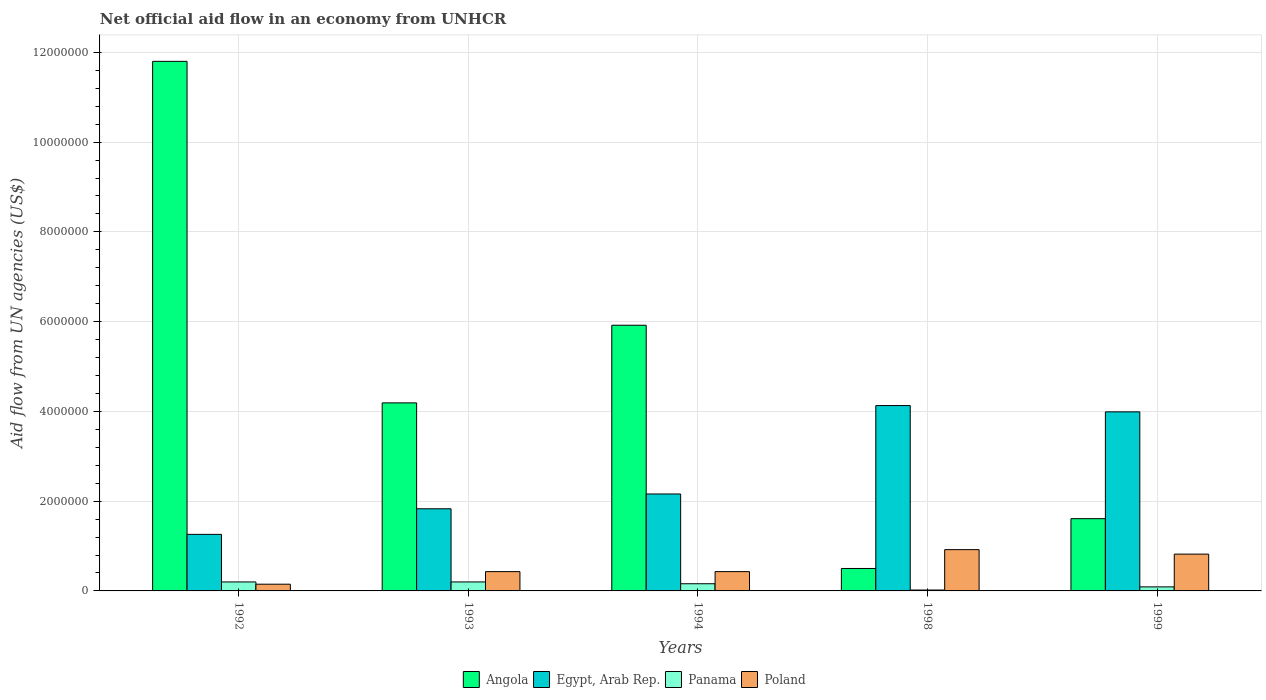How many different coloured bars are there?
Provide a short and direct response. 4. How many bars are there on the 1st tick from the left?
Your response must be concise. 4. How many bars are there on the 5th tick from the right?
Offer a terse response. 4. In how many cases, is the number of bars for a given year not equal to the number of legend labels?
Offer a very short reply. 0. What is the net official aid flow in Angola in 1994?
Your answer should be compact. 5.92e+06. Across all years, what is the maximum net official aid flow in Egypt, Arab Rep.?
Give a very brief answer. 4.13e+06. Across all years, what is the minimum net official aid flow in Egypt, Arab Rep.?
Ensure brevity in your answer.  1.26e+06. In which year was the net official aid flow in Poland maximum?
Keep it short and to the point. 1998. What is the total net official aid flow in Poland in the graph?
Offer a very short reply. 2.75e+06. What is the difference between the net official aid flow in Angola in 1992 and that in 1994?
Provide a succinct answer. 5.88e+06. What is the difference between the net official aid flow in Egypt, Arab Rep. in 1999 and the net official aid flow in Angola in 1994?
Ensure brevity in your answer.  -1.93e+06. In the year 1998, what is the difference between the net official aid flow in Poland and net official aid flow in Egypt, Arab Rep.?
Offer a very short reply. -3.21e+06. What is the ratio of the net official aid flow in Egypt, Arab Rep. in 1994 to that in 1999?
Ensure brevity in your answer.  0.54. In how many years, is the net official aid flow in Panama greater than the average net official aid flow in Panama taken over all years?
Give a very brief answer. 3. What does the 3rd bar from the left in 1999 represents?
Your response must be concise. Panama. What does the 4th bar from the right in 1994 represents?
Provide a short and direct response. Angola. Are all the bars in the graph horizontal?
Make the answer very short. No. What is the difference between two consecutive major ticks on the Y-axis?
Make the answer very short. 2.00e+06. Are the values on the major ticks of Y-axis written in scientific E-notation?
Provide a short and direct response. No. Does the graph contain grids?
Provide a short and direct response. Yes. Where does the legend appear in the graph?
Offer a terse response. Bottom center. How many legend labels are there?
Offer a terse response. 4. What is the title of the graph?
Ensure brevity in your answer.  Net official aid flow in an economy from UNHCR. Does "Vanuatu" appear as one of the legend labels in the graph?
Make the answer very short. No. What is the label or title of the X-axis?
Your response must be concise. Years. What is the label or title of the Y-axis?
Your response must be concise. Aid flow from UN agencies (US$). What is the Aid flow from UN agencies (US$) in Angola in 1992?
Make the answer very short. 1.18e+07. What is the Aid flow from UN agencies (US$) in Egypt, Arab Rep. in 1992?
Ensure brevity in your answer.  1.26e+06. What is the Aid flow from UN agencies (US$) in Poland in 1992?
Your answer should be very brief. 1.50e+05. What is the Aid flow from UN agencies (US$) of Angola in 1993?
Keep it short and to the point. 4.19e+06. What is the Aid flow from UN agencies (US$) in Egypt, Arab Rep. in 1993?
Your response must be concise. 1.83e+06. What is the Aid flow from UN agencies (US$) in Panama in 1993?
Your answer should be compact. 2.00e+05. What is the Aid flow from UN agencies (US$) in Angola in 1994?
Keep it short and to the point. 5.92e+06. What is the Aid flow from UN agencies (US$) of Egypt, Arab Rep. in 1994?
Your response must be concise. 2.16e+06. What is the Aid flow from UN agencies (US$) in Panama in 1994?
Give a very brief answer. 1.60e+05. What is the Aid flow from UN agencies (US$) of Egypt, Arab Rep. in 1998?
Offer a very short reply. 4.13e+06. What is the Aid flow from UN agencies (US$) in Panama in 1998?
Offer a very short reply. 2.00e+04. What is the Aid flow from UN agencies (US$) in Poland in 1998?
Provide a succinct answer. 9.20e+05. What is the Aid flow from UN agencies (US$) of Angola in 1999?
Offer a very short reply. 1.61e+06. What is the Aid flow from UN agencies (US$) of Egypt, Arab Rep. in 1999?
Give a very brief answer. 3.99e+06. What is the Aid flow from UN agencies (US$) of Panama in 1999?
Your answer should be compact. 9.00e+04. What is the Aid flow from UN agencies (US$) of Poland in 1999?
Give a very brief answer. 8.20e+05. Across all years, what is the maximum Aid flow from UN agencies (US$) of Angola?
Keep it short and to the point. 1.18e+07. Across all years, what is the maximum Aid flow from UN agencies (US$) in Egypt, Arab Rep.?
Make the answer very short. 4.13e+06. Across all years, what is the maximum Aid flow from UN agencies (US$) of Poland?
Give a very brief answer. 9.20e+05. Across all years, what is the minimum Aid flow from UN agencies (US$) of Angola?
Offer a terse response. 5.00e+05. Across all years, what is the minimum Aid flow from UN agencies (US$) of Egypt, Arab Rep.?
Your answer should be very brief. 1.26e+06. Across all years, what is the minimum Aid flow from UN agencies (US$) of Panama?
Your answer should be very brief. 2.00e+04. Across all years, what is the minimum Aid flow from UN agencies (US$) of Poland?
Make the answer very short. 1.50e+05. What is the total Aid flow from UN agencies (US$) of Angola in the graph?
Offer a terse response. 2.40e+07. What is the total Aid flow from UN agencies (US$) in Egypt, Arab Rep. in the graph?
Offer a very short reply. 1.34e+07. What is the total Aid flow from UN agencies (US$) of Panama in the graph?
Give a very brief answer. 6.70e+05. What is the total Aid flow from UN agencies (US$) in Poland in the graph?
Offer a very short reply. 2.75e+06. What is the difference between the Aid flow from UN agencies (US$) in Angola in 1992 and that in 1993?
Offer a very short reply. 7.61e+06. What is the difference between the Aid flow from UN agencies (US$) in Egypt, Arab Rep. in 1992 and that in 1993?
Your response must be concise. -5.70e+05. What is the difference between the Aid flow from UN agencies (US$) of Poland in 1992 and that in 1993?
Your response must be concise. -2.80e+05. What is the difference between the Aid flow from UN agencies (US$) in Angola in 1992 and that in 1994?
Offer a terse response. 5.88e+06. What is the difference between the Aid flow from UN agencies (US$) of Egypt, Arab Rep. in 1992 and that in 1994?
Offer a very short reply. -9.00e+05. What is the difference between the Aid flow from UN agencies (US$) of Panama in 1992 and that in 1994?
Give a very brief answer. 4.00e+04. What is the difference between the Aid flow from UN agencies (US$) of Poland in 1992 and that in 1994?
Your response must be concise. -2.80e+05. What is the difference between the Aid flow from UN agencies (US$) in Angola in 1992 and that in 1998?
Offer a terse response. 1.13e+07. What is the difference between the Aid flow from UN agencies (US$) of Egypt, Arab Rep. in 1992 and that in 1998?
Offer a very short reply. -2.87e+06. What is the difference between the Aid flow from UN agencies (US$) in Poland in 1992 and that in 1998?
Give a very brief answer. -7.70e+05. What is the difference between the Aid flow from UN agencies (US$) in Angola in 1992 and that in 1999?
Offer a very short reply. 1.02e+07. What is the difference between the Aid flow from UN agencies (US$) in Egypt, Arab Rep. in 1992 and that in 1999?
Provide a short and direct response. -2.73e+06. What is the difference between the Aid flow from UN agencies (US$) in Poland in 1992 and that in 1999?
Keep it short and to the point. -6.70e+05. What is the difference between the Aid flow from UN agencies (US$) of Angola in 1993 and that in 1994?
Provide a short and direct response. -1.73e+06. What is the difference between the Aid flow from UN agencies (US$) in Egypt, Arab Rep. in 1993 and that in 1994?
Your answer should be very brief. -3.30e+05. What is the difference between the Aid flow from UN agencies (US$) of Poland in 1993 and that in 1994?
Your answer should be compact. 0. What is the difference between the Aid flow from UN agencies (US$) of Angola in 1993 and that in 1998?
Your response must be concise. 3.69e+06. What is the difference between the Aid flow from UN agencies (US$) of Egypt, Arab Rep. in 1993 and that in 1998?
Your answer should be very brief. -2.30e+06. What is the difference between the Aid flow from UN agencies (US$) in Panama in 1993 and that in 1998?
Provide a succinct answer. 1.80e+05. What is the difference between the Aid flow from UN agencies (US$) in Poland in 1993 and that in 1998?
Your answer should be compact. -4.90e+05. What is the difference between the Aid flow from UN agencies (US$) of Angola in 1993 and that in 1999?
Provide a short and direct response. 2.58e+06. What is the difference between the Aid flow from UN agencies (US$) in Egypt, Arab Rep. in 1993 and that in 1999?
Your answer should be compact. -2.16e+06. What is the difference between the Aid flow from UN agencies (US$) in Poland in 1993 and that in 1999?
Make the answer very short. -3.90e+05. What is the difference between the Aid flow from UN agencies (US$) in Angola in 1994 and that in 1998?
Offer a terse response. 5.42e+06. What is the difference between the Aid flow from UN agencies (US$) in Egypt, Arab Rep. in 1994 and that in 1998?
Your answer should be compact. -1.97e+06. What is the difference between the Aid flow from UN agencies (US$) of Poland in 1994 and that in 1998?
Keep it short and to the point. -4.90e+05. What is the difference between the Aid flow from UN agencies (US$) in Angola in 1994 and that in 1999?
Keep it short and to the point. 4.31e+06. What is the difference between the Aid flow from UN agencies (US$) in Egypt, Arab Rep. in 1994 and that in 1999?
Ensure brevity in your answer.  -1.83e+06. What is the difference between the Aid flow from UN agencies (US$) of Panama in 1994 and that in 1999?
Offer a very short reply. 7.00e+04. What is the difference between the Aid flow from UN agencies (US$) in Poland in 1994 and that in 1999?
Offer a very short reply. -3.90e+05. What is the difference between the Aid flow from UN agencies (US$) in Angola in 1998 and that in 1999?
Provide a succinct answer. -1.11e+06. What is the difference between the Aid flow from UN agencies (US$) in Panama in 1998 and that in 1999?
Give a very brief answer. -7.00e+04. What is the difference between the Aid flow from UN agencies (US$) in Poland in 1998 and that in 1999?
Give a very brief answer. 1.00e+05. What is the difference between the Aid flow from UN agencies (US$) in Angola in 1992 and the Aid flow from UN agencies (US$) in Egypt, Arab Rep. in 1993?
Your answer should be very brief. 9.97e+06. What is the difference between the Aid flow from UN agencies (US$) of Angola in 1992 and the Aid flow from UN agencies (US$) of Panama in 1993?
Your answer should be very brief. 1.16e+07. What is the difference between the Aid flow from UN agencies (US$) in Angola in 1992 and the Aid flow from UN agencies (US$) in Poland in 1993?
Your answer should be very brief. 1.14e+07. What is the difference between the Aid flow from UN agencies (US$) of Egypt, Arab Rep. in 1992 and the Aid flow from UN agencies (US$) of Panama in 1993?
Keep it short and to the point. 1.06e+06. What is the difference between the Aid flow from UN agencies (US$) in Egypt, Arab Rep. in 1992 and the Aid flow from UN agencies (US$) in Poland in 1993?
Give a very brief answer. 8.30e+05. What is the difference between the Aid flow from UN agencies (US$) of Panama in 1992 and the Aid flow from UN agencies (US$) of Poland in 1993?
Keep it short and to the point. -2.30e+05. What is the difference between the Aid flow from UN agencies (US$) in Angola in 1992 and the Aid flow from UN agencies (US$) in Egypt, Arab Rep. in 1994?
Your answer should be compact. 9.64e+06. What is the difference between the Aid flow from UN agencies (US$) of Angola in 1992 and the Aid flow from UN agencies (US$) of Panama in 1994?
Keep it short and to the point. 1.16e+07. What is the difference between the Aid flow from UN agencies (US$) of Angola in 1992 and the Aid flow from UN agencies (US$) of Poland in 1994?
Offer a very short reply. 1.14e+07. What is the difference between the Aid flow from UN agencies (US$) of Egypt, Arab Rep. in 1992 and the Aid flow from UN agencies (US$) of Panama in 1994?
Provide a short and direct response. 1.10e+06. What is the difference between the Aid flow from UN agencies (US$) in Egypt, Arab Rep. in 1992 and the Aid flow from UN agencies (US$) in Poland in 1994?
Offer a very short reply. 8.30e+05. What is the difference between the Aid flow from UN agencies (US$) of Panama in 1992 and the Aid flow from UN agencies (US$) of Poland in 1994?
Provide a succinct answer. -2.30e+05. What is the difference between the Aid flow from UN agencies (US$) in Angola in 1992 and the Aid flow from UN agencies (US$) in Egypt, Arab Rep. in 1998?
Provide a short and direct response. 7.67e+06. What is the difference between the Aid flow from UN agencies (US$) of Angola in 1992 and the Aid flow from UN agencies (US$) of Panama in 1998?
Your response must be concise. 1.18e+07. What is the difference between the Aid flow from UN agencies (US$) in Angola in 1992 and the Aid flow from UN agencies (US$) in Poland in 1998?
Provide a succinct answer. 1.09e+07. What is the difference between the Aid flow from UN agencies (US$) in Egypt, Arab Rep. in 1992 and the Aid flow from UN agencies (US$) in Panama in 1998?
Make the answer very short. 1.24e+06. What is the difference between the Aid flow from UN agencies (US$) of Egypt, Arab Rep. in 1992 and the Aid flow from UN agencies (US$) of Poland in 1998?
Provide a short and direct response. 3.40e+05. What is the difference between the Aid flow from UN agencies (US$) in Panama in 1992 and the Aid flow from UN agencies (US$) in Poland in 1998?
Provide a succinct answer. -7.20e+05. What is the difference between the Aid flow from UN agencies (US$) of Angola in 1992 and the Aid flow from UN agencies (US$) of Egypt, Arab Rep. in 1999?
Provide a succinct answer. 7.81e+06. What is the difference between the Aid flow from UN agencies (US$) in Angola in 1992 and the Aid flow from UN agencies (US$) in Panama in 1999?
Offer a terse response. 1.17e+07. What is the difference between the Aid flow from UN agencies (US$) of Angola in 1992 and the Aid flow from UN agencies (US$) of Poland in 1999?
Keep it short and to the point. 1.10e+07. What is the difference between the Aid flow from UN agencies (US$) in Egypt, Arab Rep. in 1992 and the Aid flow from UN agencies (US$) in Panama in 1999?
Make the answer very short. 1.17e+06. What is the difference between the Aid flow from UN agencies (US$) of Panama in 1992 and the Aid flow from UN agencies (US$) of Poland in 1999?
Offer a terse response. -6.20e+05. What is the difference between the Aid flow from UN agencies (US$) in Angola in 1993 and the Aid flow from UN agencies (US$) in Egypt, Arab Rep. in 1994?
Your response must be concise. 2.03e+06. What is the difference between the Aid flow from UN agencies (US$) of Angola in 1993 and the Aid flow from UN agencies (US$) of Panama in 1994?
Keep it short and to the point. 4.03e+06. What is the difference between the Aid flow from UN agencies (US$) in Angola in 1993 and the Aid flow from UN agencies (US$) in Poland in 1994?
Your answer should be very brief. 3.76e+06. What is the difference between the Aid flow from UN agencies (US$) in Egypt, Arab Rep. in 1993 and the Aid flow from UN agencies (US$) in Panama in 1994?
Offer a very short reply. 1.67e+06. What is the difference between the Aid flow from UN agencies (US$) in Egypt, Arab Rep. in 1993 and the Aid flow from UN agencies (US$) in Poland in 1994?
Provide a short and direct response. 1.40e+06. What is the difference between the Aid flow from UN agencies (US$) in Panama in 1993 and the Aid flow from UN agencies (US$) in Poland in 1994?
Your response must be concise. -2.30e+05. What is the difference between the Aid flow from UN agencies (US$) in Angola in 1993 and the Aid flow from UN agencies (US$) in Egypt, Arab Rep. in 1998?
Keep it short and to the point. 6.00e+04. What is the difference between the Aid flow from UN agencies (US$) in Angola in 1993 and the Aid flow from UN agencies (US$) in Panama in 1998?
Your response must be concise. 4.17e+06. What is the difference between the Aid flow from UN agencies (US$) of Angola in 1993 and the Aid flow from UN agencies (US$) of Poland in 1998?
Provide a succinct answer. 3.27e+06. What is the difference between the Aid flow from UN agencies (US$) in Egypt, Arab Rep. in 1993 and the Aid flow from UN agencies (US$) in Panama in 1998?
Give a very brief answer. 1.81e+06. What is the difference between the Aid flow from UN agencies (US$) in Egypt, Arab Rep. in 1993 and the Aid flow from UN agencies (US$) in Poland in 1998?
Provide a short and direct response. 9.10e+05. What is the difference between the Aid flow from UN agencies (US$) in Panama in 1993 and the Aid flow from UN agencies (US$) in Poland in 1998?
Give a very brief answer. -7.20e+05. What is the difference between the Aid flow from UN agencies (US$) in Angola in 1993 and the Aid flow from UN agencies (US$) in Panama in 1999?
Offer a terse response. 4.10e+06. What is the difference between the Aid flow from UN agencies (US$) of Angola in 1993 and the Aid flow from UN agencies (US$) of Poland in 1999?
Offer a very short reply. 3.37e+06. What is the difference between the Aid flow from UN agencies (US$) of Egypt, Arab Rep. in 1993 and the Aid flow from UN agencies (US$) of Panama in 1999?
Your response must be concise. 1.74e+06. What is the difference between the Aid flow from UN agencies (US$) in Egypt, Arab Rep. in 1993 and the Aid flow from UN agencies (US$) in Poland in 1999?
Your answer should be very brief. 1.01e+06. What is the difference between the Aid flow from UN agencies (US$) in Panama in 1993 and the Aid flow from UN agencies (US$) in Poland in 1999?
Your response must be concise. -6.20e+05. What is the difference between the Aid flow from UN agencies (US$) in Angola in 1994 and the Aid flow from UN agencies (US$) in Egypt, Arab Rep. in 1998?
Give a very brief answer. 1.79e+06. What is the difference between the Aid flow from UN agencies (US$) in Angola in 1994 and the Aid flow from UN agencies (US$) in Panama in 1998?
Provide a succinct answer. 5.90e+06. What is the difference between the Aid flow from UN agencies (US$) of Angola in 1994 and the Aid flow from UN agencies (US$) of Poland in 1998?
Provide a short and direct response. 5.00e+06. What is the difference between the Aid flow from UN agencies (US$) in Egypt, Arab Rep. in 1994 and the Aid flow from UN agencies (US$) in Panama in 1998?
Offer a very short reply. 2.14e+06. What is the difference between the Aid flow from UN agencies (US$) in Egypt, Arab Rep. in 1994 and the Aid flow from UN agencies (US$) in Poland in 1998?
Offer a terse response. 1.24e+06. What is the difference between the Aid flow from UN agencies (US$) in Panama in 1994 and the Aid flow from UN agencies (US$) in Poland in 1998?
Give a very brief answer. -7.60e+05. What is the difference between the Aid flow from UN agencies (US$) in Angola in 1994 and the Aid flow from UN agencies (US$) in Egypt, Arab Rep. in 1999?
Ensure brevity in your answer.  1.93e+06. What is the difference between the Aid flow from UN agencies (US$) in Angola in 1994 and the Aid flow from UN agencies (US$) in Panama in 1999?
Your response must be concise. 5.83e+06. What is the difference between the Aid flow from UN agencies (US$) of Angola in 1994 and the Aid flow from UN agencies (US$) of Poland in 1999?
Offer a very short reply. 5.10e+06. What is the difference between the Aid flow from UN agencies (US$) in Egypt, Arab Rep. in 1994 and the Aid flow from UN agencies (US$) in Panama in 1999?
Give a very brief answer. 2.07e+06. What is the difference between the Aid flow from UN agencies (US$) in Egypt, Arab Rep. in 1994 and the Aid flow from UN agencies (US$) in Poland in 1999?
Keep it short and to the point. 1.34e+06. What is the difference between the Aid flow from UN agencies (US$) in Panama in 1994 and the Aid flow from UN agencies (US$) in Poland in 1999?
Give a very brief answer. -6.60e+05. What is the difference between the Aid flow from UN agencies (US$) in Angola in 1998 and the Aid flow from UN agencies (US$) in Egypt, Arab Rep. in 1999?
Your answer should be very brief. -3.49e+06. What is the difference between the Aid flow from UN agencies (US$) of Angola in 1998 and the Aid flow from UN agencies (US$) of Panama in 1999?
Offer a very short reply. 4.10e+05. What is the difference between the Aid flow from UN agencies (US$) in Angola in 1998 and the Aid flow from UN agencies (US$) in Poland in 1999?
Make the answer very short. -3.20e+05. What is the difference between the Aid flow from UN agencies (US$) of Egypt, Arab Rep. in 1998 and the Aid flow from UN agencies (US$) of Panama in 1999?
Your answer should be compact. 4.04e+06. What is the difference between the Aid flow from UN agencies (US$) of Egypt, Arab Rep. in 1998 and the Aid flow from UN agencies (US$) of Poland in 1999?
Give a very brief answer. 3.31e+06. What is the difference between the Aid flow from UN agencies (US$) of Panama in 1998 and the Aid flow from UN agencies (US$) of Poland in 1999?
Provide a succinct answer. -8.00e+05. What is the average Aid flow from UN agencies (US$) in Angola per year?
Offer a very short reply. 4.80e+06. What is the average Aid flow from UN agencies (US$) in Egypt, Arab Rep. per year?
Offer a terse response. 2.67e+06. What is the average Aid flow from UN agencies (US$) in Panama per year?
Keep it short and to the point. 1.34e+05. What is the average Aid flow from UN agencies (US$) in Poland per year?
Your response must be concise. 5.50e+05. In the year 1992, what is the difference between the Aid flow from UN agencies (US$) in Angola and Aid flow from UN agencies (US$) in Egypt, Arab Rep.?
Provide a short and direct response. 1.05e+07. In the year 1992, what is the difference between the Aid flow from UN agencies (US$) of Angola and Aid flow from UN agencies (US$) of Panama?
Give a very brief answer. 1.16e+07. In the year 1992, what is the difference between the Aid flow from UN agencies (US$) in Angola and Aid flow from UN agencies (US$) in Poland?
Provide a succinct answer. 1.16e+07. In the year 1992, what is the difference between the Aid flow from UN agencies (US$) in Egypt, Arab Rep. and Aid flow from UN agencies (US$) in Panama?
Keep it short and to the point. 1.06e+06. In the year 1992, what is the difference between the Aid flow from UN agencies (US$) in Egypt, Arab Rep. and Aid flow from UN agencies (US$) in Poland?
Give a very brief answer. 1.11e+06. In the year 1992, what is the difference between the Aid flow from UN agencies (US$) in Panama and Aid flow from UN agencies (US$) in Poland?
Keep it short and to the point. 5.00e+04. In the year 1993, what is the difference between the Aid flow from UN agencies (US$) in Angola and Aid flow from UN agencies (US$) in Egypt, Arab Rep.?
Ensure brevity in your answer.  2.36e+06. In the year 1993, what is the difference between the Aid flow from UN agencies (US$) in Angola and Aid flow from UN agencies (US$) in Panama?
Provide a short and direct response. 3.99e+06. In the year 1993, what is the difference between the Aid flow from UN agencies (US$) of Angola and Aid flow from UN agencies (US$) of Poland?
Offer a terse response. 3.76e+06. In the year 1993, what is the difference between the Aid flow from UN agencies (US$) in Egypt, Arab Rep. and Aid flow from UN agencies (US$) in Panama?
Your answer should be compact. 1.63e+06. In the year 1993, what is the difference between the Aid flow from UN agencies (US$) of Egypt, Arab Rep. and Aid flow from UN agencies (US$) of Poland?
Your answer should be compact. 1.40e+06. In the year 1993, what is the difference between the Aid flow from UN agencies (US$) in Panama and Aid flow from UN agencies (US$) in Poland?
Provide a succinct answer. -2.30e+05. In the year 1994, what is the difference between the Aid flow from UN agencies (US$) of Angola and Aid flow from UN agencies (US$) of Egypt, Arab Rep.?
Your answer should be very brief. 3.76e+06. In the year 1994, what is the difference between the Aid flow from UN agencies (US$) of Angola and Aid flow from UN agencies (US$) of Panama?
Keep it short and to the point. 5.76e+06. In the year 1994, what is the difference between the Aid flow from UN agencies (US$) in Angola and Aid flow from UN agencies (US$) in Poland?
Keep it short and to the point. 5.49e+06. In the year 1994, what is the difference between the Aid flow from UN agencies (US$) of Egypt, Arab Rep. and Aid flow from UN agencies (US$) of Poland?
Your answer should be compact. 1.73e+06. In the year 1998, what is the difference between the Aid flow from UN agencies (US$) in Angola and Aid flow from UN agencies (US$) in Egypt, Arab Rep.?
Make the answer very short. -3.63e+06. In the year 1998, what is the difference between the Aid flow from UN agencies (US$) in Angola and Aid flow from UN agencies (US$) in Poland?
Offer a terse response. -4.20e+05. In the year 1998, what is the difference between the Aid flow from UN agencies (US$) in Egypt, Arab Rep. and Aid flow from UN agencies (US$) in Panama?
Ensure brevity in your answer.  4.11e+06. In the year 1998, what is the difference between the Aid flow from UN agencies (US$) of Egypt, Arab Rep. and Aid flow from UN agencies (US$) of Poland?
Provide a succinct answer. 3.21e+06. In the year 1998, what is the difference between the Aid flow from UN agencies (US$) in Panama and Aid flow from UN agencies (US$) in Poland?
Ensure brevity in your answer.  -9.00e+05. In the year 1999, what is the difference between the Aid flow from UN agencies (US$) of Angola and Aid flow from UN agencies (US$) of Egypt, Arab Rep.?
Your answer should be compact. -2.38e+06. In the year 1999, what is the difference between the Aid flow from UN agencies (US$) of Angola and Aid flow from UN agencies (US$) of Panama?
Offer a very short reply. 1.52e+06. In the year 1999, what is the difference between the Aid flow from UN agencies (US$) in Angola and Aid flow from UN agencies (US$) in Poland?
Give a very brief answer. 7.90e+05. In the year 1999, what is the difference between the Aid flow from UN agencies (US$) of Egypt, Arab Rep. and Aid flow from UN agencies (US$) of Panama?
Offer a very short reply. 3.90e+06. In the year 1999, what is the difference between the Aid flow from UN agencies (US$) of Egypt, Arab Rep. and Aid flow from UN agencies (US$) of Poland?
Your answer should be very brief. 3.17e+06. In the year 1999, what is the difference between the Aid flow from UN agencies (US$) in Panama and Aid flow from UN agencies (US$) in Poland?
Provide a succinct answer. -7.30e+05. What is the ratio of the Aid flow from UN agencies (US$) of Angola in 1992 to that in 1993?
Your answer should be compact. 2.82. What is the ratio of the Aid flow from UN agencies (US$) of Egypt, Arab Rep. in 1992 to that in 1993?
Make the answer very short. 0.69. What is the ratio of the Aid flow from UN agencies (US$) in Panama in 1992 to that in 1993?
Offer a terse response. 1. What is the ratio of the Aid flow from UN agencies (US$) of Poland in 1992 to that in 1993?
Provide a succinct answer. 0.35. What is the ratio of the Aid flow from UN agencies (US$) in Angola in 1992 to that in 1994?
Your answer should be very brief. 1.99. What is the ratio of the Aid flow from UN agencies (US$) in Egypt, Arab Rep. in 1992 to that in 1994?
Keep it short and to the point. 0.58. What is the ratio of the Aid flow from UN agencies (US$) of Panama in 1992 to that in 1994?
Offer a very short reply. 1.25. What is the ratio of the Aid flow from UN agencies (US$) in Poland in 1992 to that in 1994?
Provide a succinct answer. 0.35. What is the ratio of the Aid flow from UN agencies (US$) in Angola in 1992 to that in 1998?
Provide a succinct answer. 23.6. What is the ratio of the Aid flow from UN agencies (US$) of Egypt, Arab Rep. in 1992 to that in 1998?
Your answer should be very brief. 0.31. What is the ratio of the Aid flow from UN agencies (US$) of Poland in 1992 to that in 1998?
Your response must be concise. 0.16. What is the ratio of the Aid flow from UN agencies (US$) of Angola in 1992 to that in 1999?
Ensure brevity in your answer.  7.33. What is the ratio of the Aid flow from UN agencies (US$) in Egypt, Arab Rep. in 1992 to that in 1999?
Ensure brevity in your answer.  0.32. What is the ratio of the Aid flow from UN agencies (US$) in Panama in 1992 to that in 1999?
Give a very brief answer. 2.22. What is the ratio of the Aid flow from UN agencies (US$) of Poland in 1992 to that in 1999?
Provide a short and direct response. 0.18. What is the ratio of the Aid flow from UN agencies (US$) in Angola in 1993 to that in 1994?
Your answer should be compact. 0.71. What is the ratio of the Aid flow from UN agencies (US$) in Egypt, Arab Rep. in 1993 to that in 1994?
Give a very brief answer. 0.85. What is the ratio of the Aid flow from UN agencies (US$) of Poland in 1993 to that in 1994?
Your response must be concise. 1. What is the ratio of the Aid flow from UN agencies (US$) of Angola in 1993 to that in 1998?
Your response must be concise. 8.38. What is the ratio of the Aid flow from UN agencies (US$) in Egypt, Arab Rep. in 1993 to that in 1998?
Your answer should be very brief. 0.44. What is the ratio of the Aid flow from UN agencies (US$) of Panama in 1993 to that in 1998?
Make the answer very short. 10. What is the ratio of the Aid flow from UN agencies (US$) of Poland in 1993 to that in 1998?
Ensure brevity in your answer.  0.47. What is the ratio of the Aid flow from UN agencies (US$) of Angola in 1993 to that in 1999?
Your response must be concise. 2.6. What is the ratio of the Aid flow from UN agencies (US$) of Egypt, Arab Rep. in 1993 to that in 1999?
Ensure brevity in your answer.  0.46. What is the ratio of the Aid flow from UN agencies (US$) of Panama in 1993 to that in 1999?
Your answer should be compact. 2.22. What is the ratio of the Aid flow from UN agencies (US$) in Poland in 1993 to that in 1999?
Give a very brief answer. 0.52. What is the ratio of the Aid flow from UN agencies (US$) in Angola in 1994 to that in 1998?
Make the answer very short. 11.84. What is the ratio of the Aid flow from UN agencies (US$) of Egypt, Arab Rep. in 1994 to that in 1998?
Your answer should be very brief. 0.52. What is the ratio of the Aid flow from UN agencies (US$) of Poland in 1994 to that in 1998?
Your response must be concise. 0.47. What is the ratio of the Aid flow from UN agencies (US$) in Angola in 1994 to that in 1999?
Keep it short and to the point. 3.68. What is the ratio of the Aid flow from UN agencies (US$) of Egypt, Arab Rep. in 1994 to that in 1999?
Offer a very short reply. 0.54. What is the ratio of the Aid flow from UN agencies (US$) of Panama in 1994 to that in 1999?
Provide a succinct answer. 1.78. What is the ratio of the Aid flow from UN agencies (US$) in Poland in 1994 to that in 1999?
Your answer should be compact. 0.52. What is the ratio of the Aid flow from UN agencies (US$) of Angola in 1998 to that in 1999?
Your answer should be very brief. 0.31. What is the ratio of the Aid flow from UN agencies (US$) in Egypt, Arab Rep. in 1998 to that in 1999?
Keep it short and to the point. 1.04. What is the ratio of the Aid flow from UN agencies (US$) in Panama in 1998 to that in 1999?
Keep it short and to the point. 0.22. What is the ratio of the Aid flow from UN agencies (US$) in Poland in 1998 to that in 1999?
Ensure brevity in your answer.  1.12. What is the difference between the highest and the second highest Aid flow from UN agencies (US$) in Angola?
Give a very brief answer. 5.88e+06. What is the difference between the highest and the second highest Aid flow from UN agencies (US$) of Egypt, Arab Rep.?
Your response must be concise. 1.40e+05. What is the difference between the highest and the second highest Aid flow from UN agencies (US$) of Poland?
Provide a short and direct response. 1.00e+05. What is the difference between the highest and the lowest Aid flow from UN agencies (US$) of Angola?
Offer a terse response. 1.13e+07. What is the difference between the highest and the lowest Aid flow from UN agencies (US$) in Egypt, Arab Rep.?
Your answer should be very brief. 2.87e+06. What is the difference between the highest and the lowest Aid flow from UN agencies (US$) of Poland?
Your answer should be compact. 7.70e+05. 